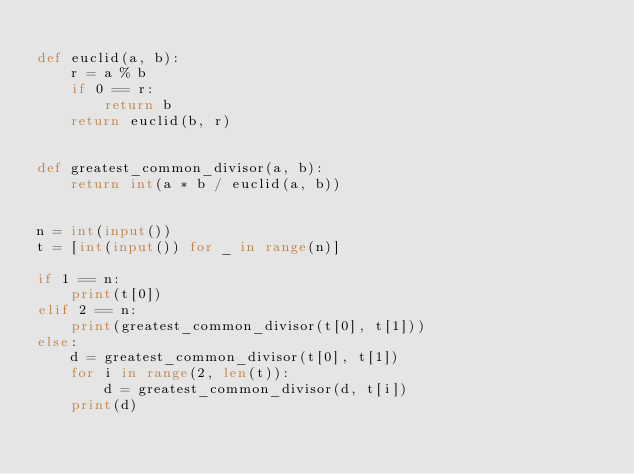Convert code to text. <code><loc_0><loc_0><loc_500><loc_500><_Python_>
def euclid(a, b):
    r = a % b
    if 0 == r:
        return b
    return euclid(b, r)


def greatest_common_divisor(a, b):
    return int(a * b / euclid(a, b))


n = int(input())
t = [int(input()) for _ in range(n)]

if 1 == n:
    print(t[0])
elif 2 == n:
    print(greatest_common_divisor(t[0], t[1]))
else:
    d = greatest_common_divisor(t[0], t[1])
    for i in range(2, len(t)):
        d = greatest_common_divisor(d, t[i])
    print(d)
</code> 